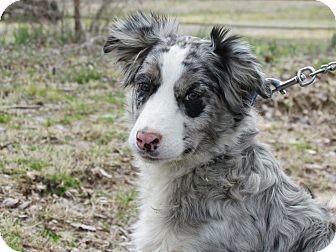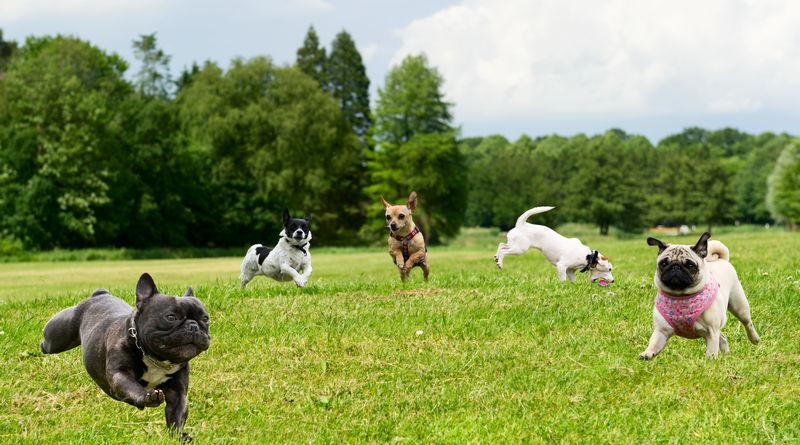The first image is the image on the left, the second image is the image on the right. For the images displayed, is the sentence "The left image includes one brown-and-white dog, and the right image shows one multi-colored spotted dog." factually correct? Answer yes or no. No. The first image is the image on the left, the second image is the image on the right. Considering the images on both sides, is "There is no more than two dogs." valid? Answer yes or no. No. 